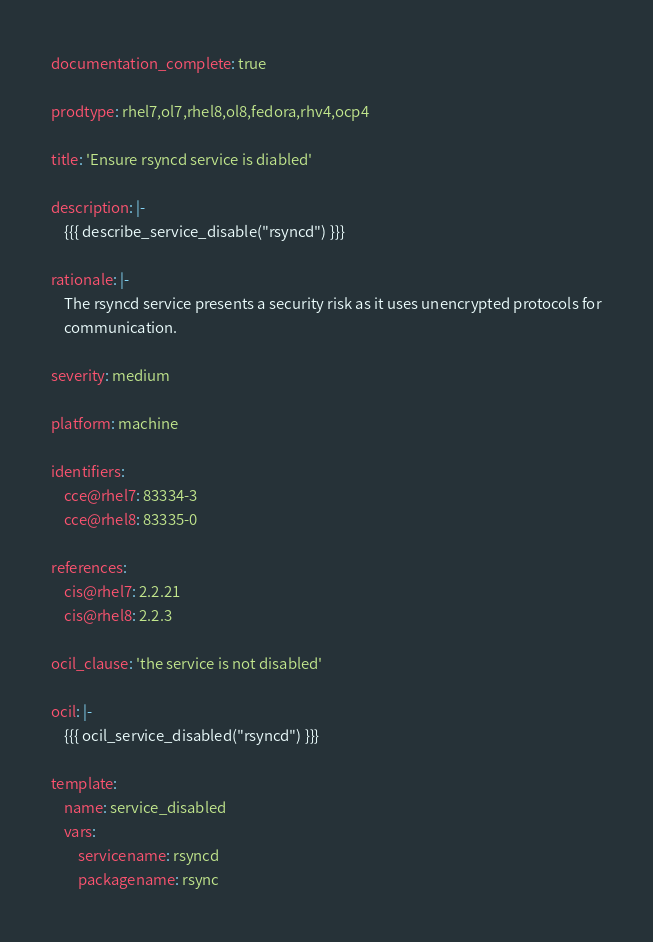<code> <loc_0><loc_0><loc_500><loc_500><_YAML_>documentation_complete: true

prodtype: rhel7,ol7,rhel8,ol8,fedora,rhv4,ocp4

title: 'Ensure rsyncd service is diabled'

description: |-
    {{{ describe_service_disable("rsyncd") }}}

rationale: |-
    The rsyncd service presents a security risk as it uses unencrypted protocols for
    communication.

severity: medium

platform: machine

identifiers:
    cce@rhel7: 83334-3
    cce@rhel8: 83335-0

references:
    cis@rhel7: 2.2.21
    cis@rhel8: 2.2.3

ocil_clause: 'the service is not disabled'

ocil: |-
    {{{ ocil_service_disabled("rsyncd") }}}

template:
    name: service_disabled
    vars:
        servicename: rsyncd
        packagename: rsync
</code> 